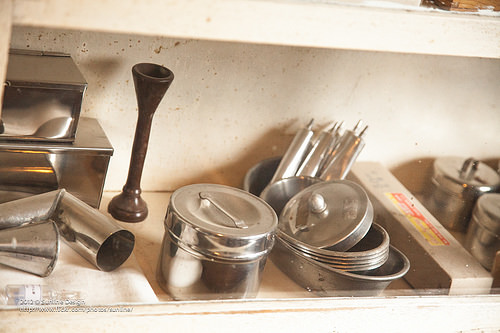<image>
Is there a wall next to the lunch box? Yes. The wall is positioned adjacent to the lunch box, located nearby in the same general area. 